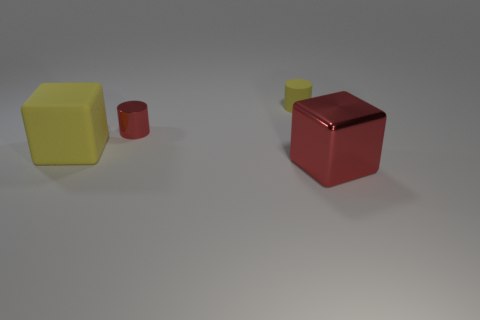Do the rubber thing that is behind the metal cylinder and the big yellow cube have the same size?
Offer a very short reply. No. The object that is both to the left of the big red shiny object and to the right of the small shiny cylinder has what shape?
Provide a short and direct response. Cylinder. There is a small shiny cylinder; is it the same color as the big object that is right of the tiny rubber object?
Make the answer very short. Yes. There is a metallic thing behind the block that is left of the matte thing that is behind the tiny red cylinder; what color is it?
Your answer should be very brief. Red. The other tiny thing that is the same shape as the small yellow thing is what color?
Offer a terse response. Red. Are there the same number of small red shiny objects behind the red metallic cylinder and tiny red cylinders?
Give a very brief answer. No. How many cylinders are large objects or yellow things?
Make the answer very short. 1. What color is the block that is the same material as the tiny yellow cylinder?
Offer a very short reply. Yellow. Does the small red thing have the same material as the large object that is on the left side of the yellow rubber cylinder?
Provide a short and direct response. No. How many objects are either purple metallic things or red things?
Offer a terse response. 2. 